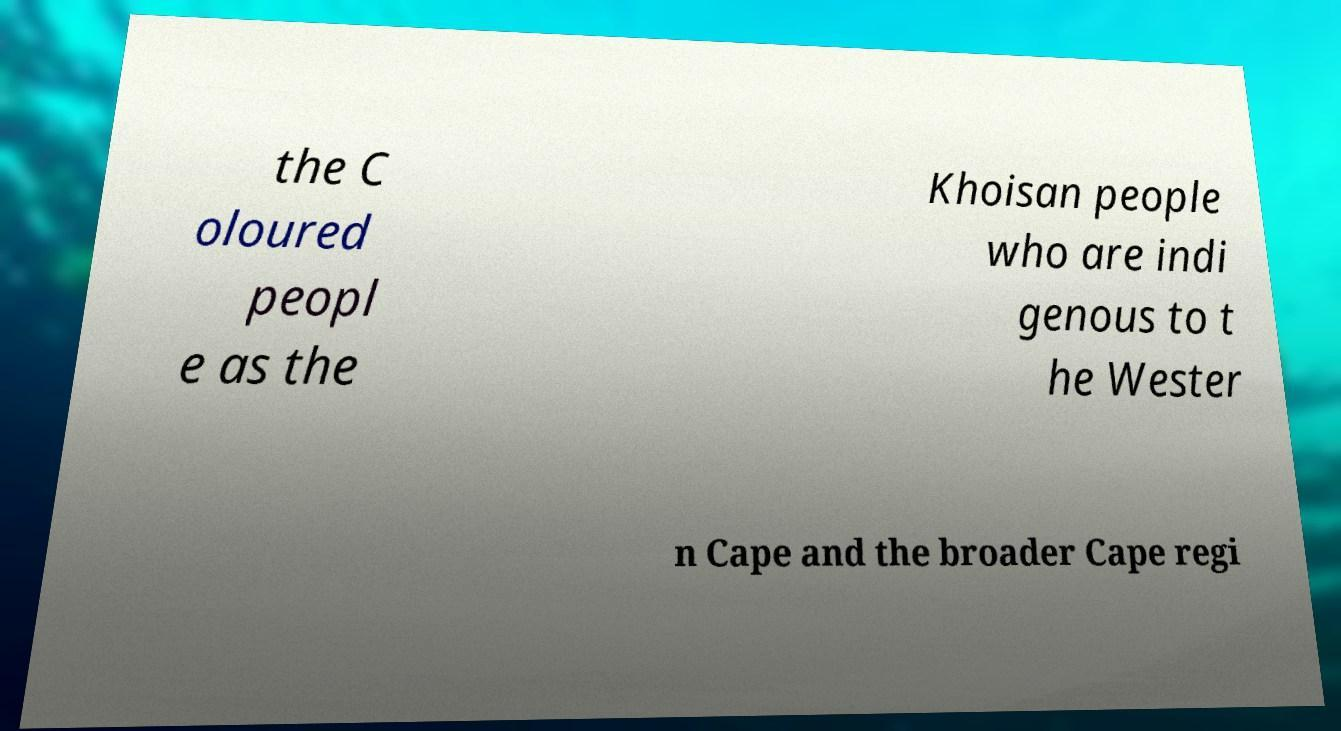Can you accurately transcribe the text from the provided image for me? the C oloured peopl e as the Khoisan people who are indi genous to t he Wester n Cape and the broader Cape regi 